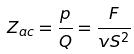Convert formula to latex. <formula><loc_0><loc_0><loc_500><loc_500>Z _ { a c } = \frac { p } { Q } = \frac { F } { v S ^ { 2 } }</formula> 